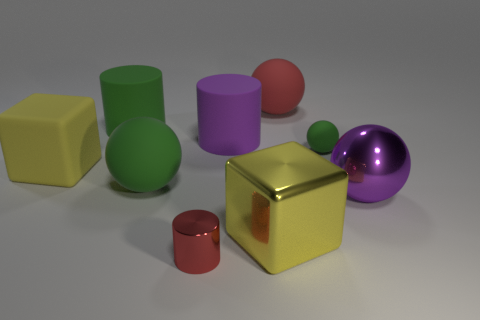Subtract all cyan cubes. How many green balls are left? 2 Subtract all purple balls. How many balls are left? 3 Subtract all green cylinders. How many cylinders are left? 2 Subtract 1 spheres. How many spheres are left? 3 Subtract all cubes. How many objects are left? 7 Subtract all brown spheres. Subtract all brown cubes. How many spheres are left? 4 Subtract all big green rubber spheres. Subtract all rubber cylinders. How many objects are left? 6 Add 1 red rubber spheres. How many red rubber spheres are left? 2 Add 5 small brown metallic things. How many small brown metallic things exist? 5 Subtract 0 brown cylinders. How many objects are left? 9 